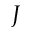<formula> <loc_0><loc_0><loc_500><loc_500>J</formula> 